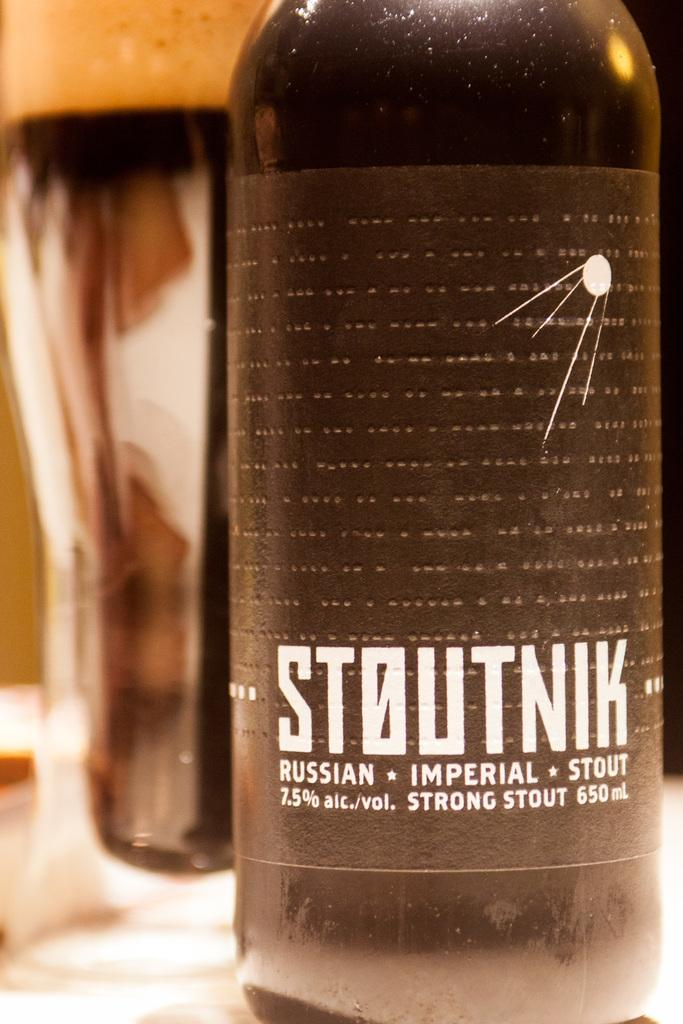What object can be seen in the picture with a label? There is a bottle in the picture with text on its label. What other object is related to the bottle in the picture? There is a glass in the picture. What type of background is visible in the picture? There is a wall in the picture. What type of linen is draped over the bottle in the picture? There is no linen draped over the bottle in the picture; it only shows the bottle with a label and a glass. 